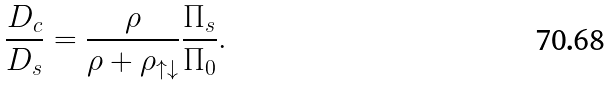Convert formula to latex. <formula><loc_0><loc_0><loc_500><loc_500>\frac { D _ { c } } { D _ { s } } = \frac { \rho } { \rho + \rho _ { \uparrow \downarrow } } \frac { \Pi _ { s } } { \Pi _ { 0 } } .</formula> 